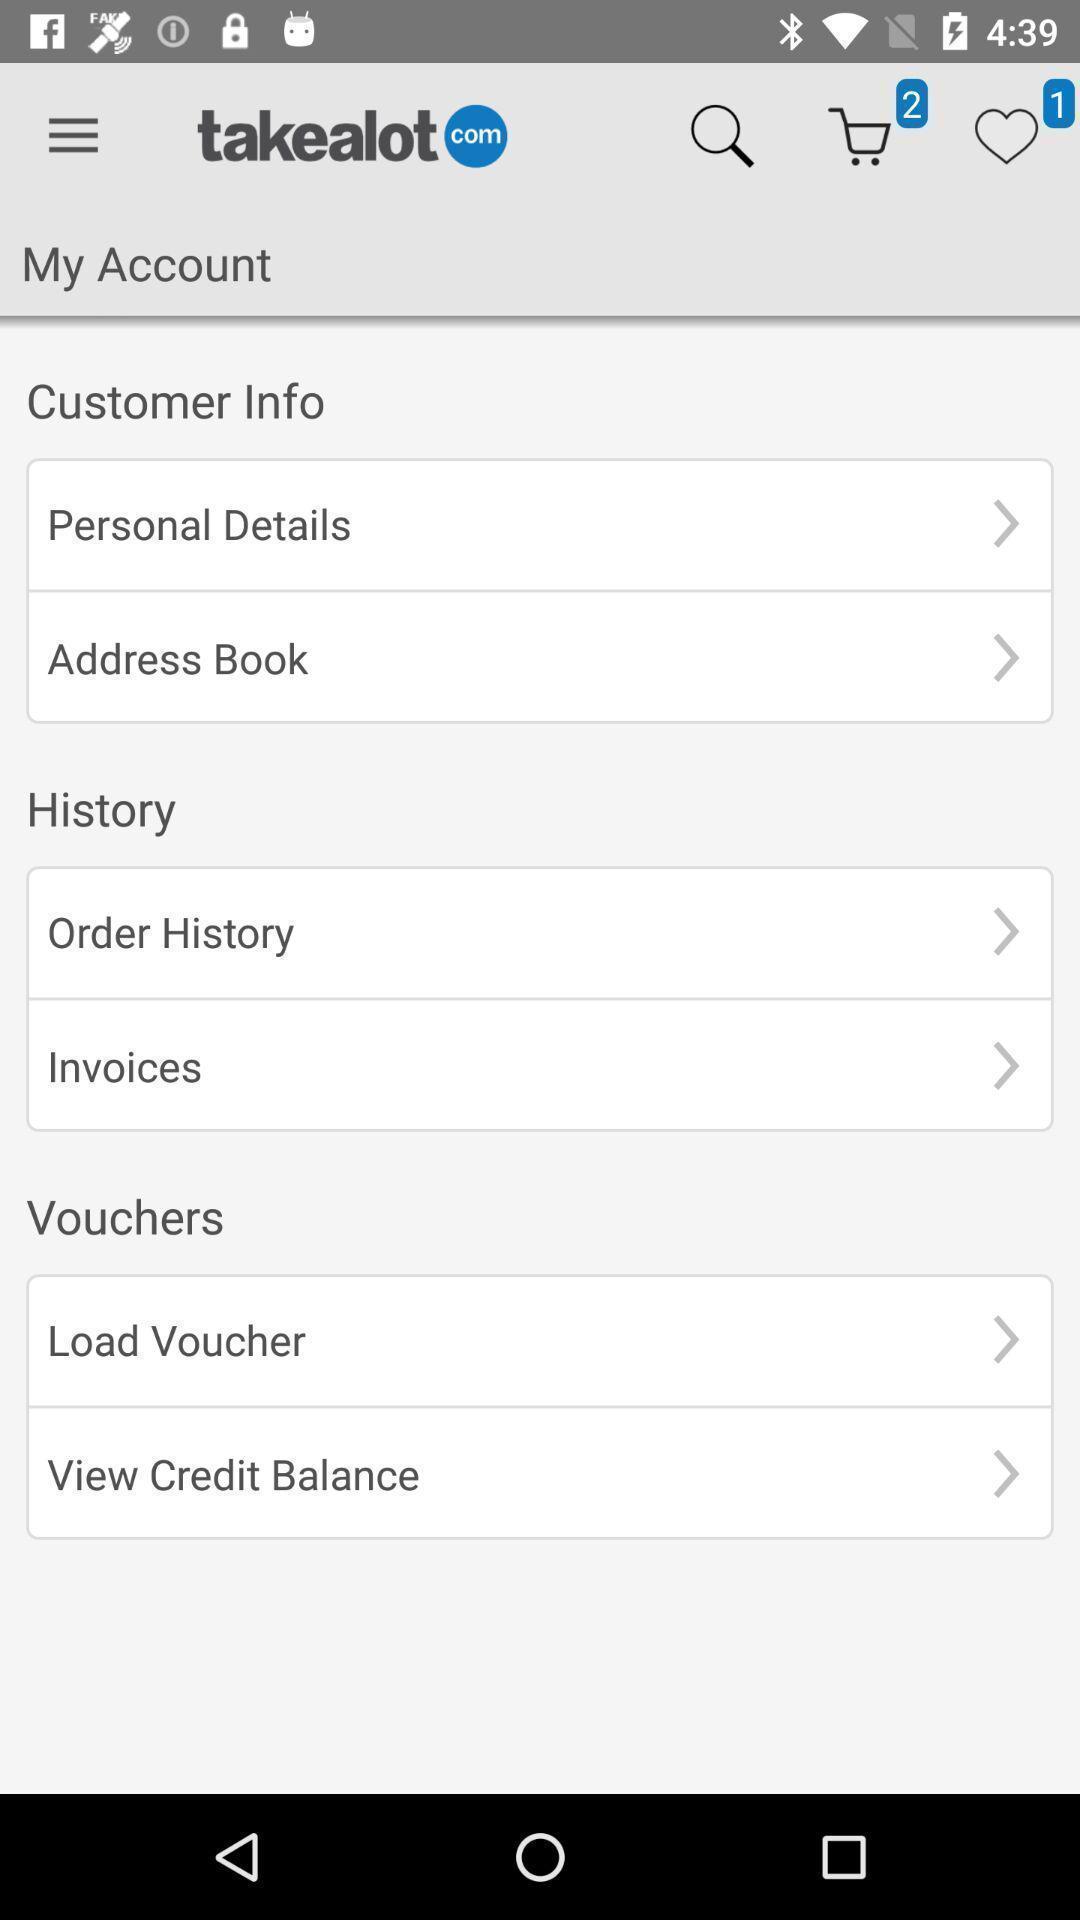Provide a textual representation of this image. Screen showing customer info and history in an shopping application. 